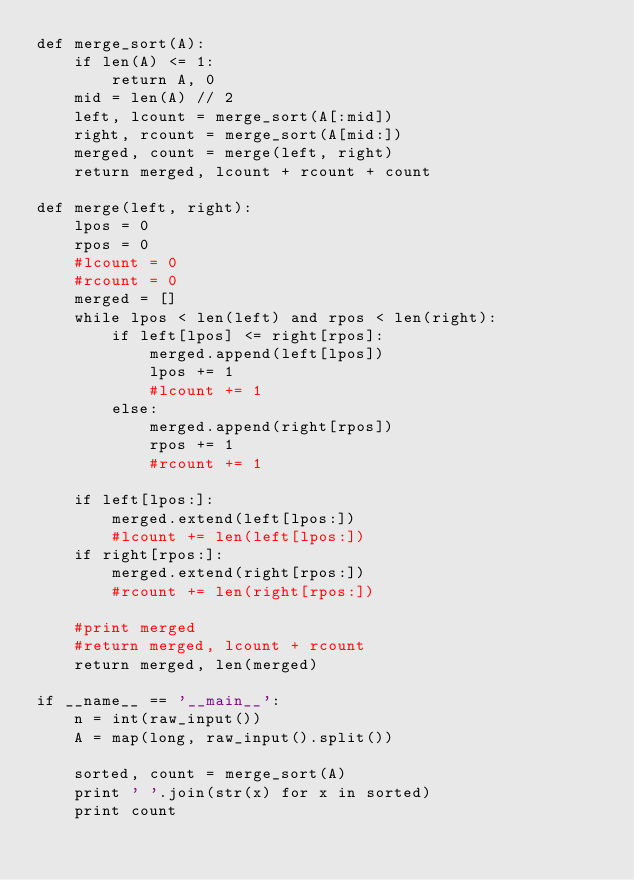<code> <loc_0><loc_0><loc_500><loc_500><_Python_>def merge_sort(A):
    if len(A) <= 1:
        return A, 0
    mid = len(A) // 2
    left, lcount = merge_sort(A[:mid])
    right, rcount = merge_sort(A[mid:])
    merged, count = merge(left, right)
    return merged, lcount + rcount + count

def merge(left, right):
    lpos = 0
    rpos = 0
    #lcount = 0
    #rcount = 0
    merged = []
    while lpos < len(left) and rpos < len(right):
        if left[lpos] <= right[rpos]:
            merged.append(left[lpos])
            lpos += 1
            #lcount += 1
        else:
            merged.append(right[rpos])
            rpos += 1
            #rcount += 1
    
    if left[lpos:]:
        merged.extend(left[lpos:])
        #lcount += len(left[lpos:])
    if right[rpos:]:
        merged.extend(right[rpos:])
        #rcount += len(right[rpos:])
    
    #print merged
    #return merged, lcount + rcount
    return merged, len(merged)

if __name__ == '__main__':
    n = int(raw_input())
    A = map(long, raw_input().split())
    
    sorted, count = merge_sort(A)
    print ' '.join(str(x) for x in sorted)
    print count</code> 